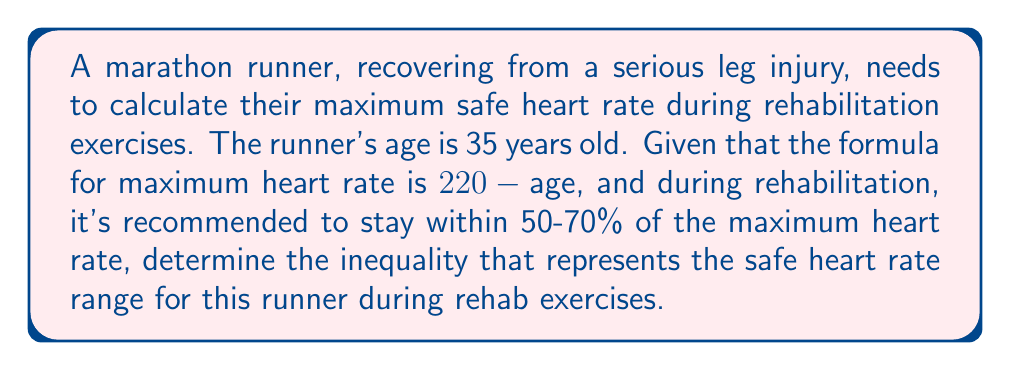Help me with this question. Let's approach this step-by-step:

1) First, calculate the maximum heart rate:
   $\text{Max Heart Rate} = 220 - \text{age}$
   $\text{Max Heart Rate} = 220 - 35 = 185$ beats per minute (bpm)

2) Now, we need to find 50% and 70% of this maximum:
   
   50%: $0.50 \times 185 = 92.5$ bpm
   70%: $0.70 \times 185 = 129.5$ bpm

3) The safe heart rate range should be between these two values. Let's call the safe heart rate $x$.

4) We can express this as an inequality:
   
   $92.5 \leq x \leq 129.5$

5) To make this more precise for practical use, we'll round to the nearest whole number:
   
   $93 \leq x \leq 130$

This inequality represents the safe range for the runner's heart rate during rehabilitation exercises.
Answer: $93 \leq x \leq 130$, where $x$ is the heart rate in beats per minute. 